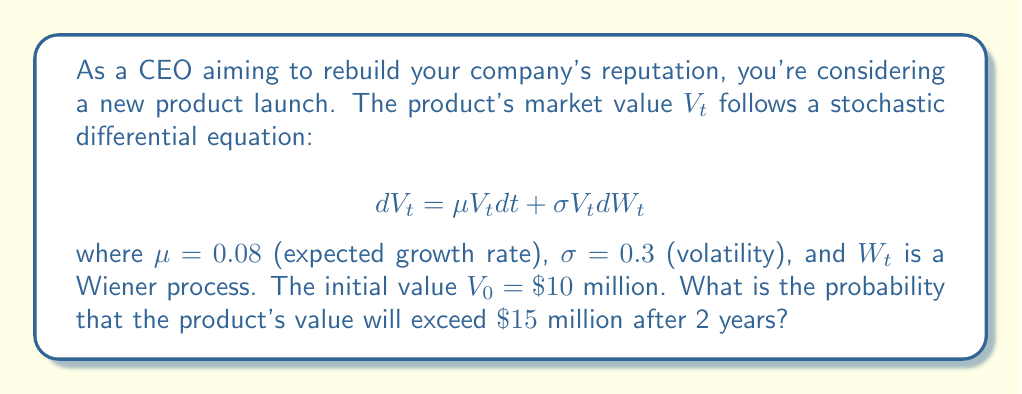Help me with this question. To solve this problem, we'll use the properties of geometric Brownian motion:

1) The solution to the SDE is given by:
   $$V_t = V_0 \exp\left(\left(\mu - \frac{\sigma^2}{2}\right)t + \sigma W_t\right)$$

2) $\ln(V_t)$ follows a normal distribution with:
   Mean: $\ln(V_0) + \left(\mu - \frac{\sigma^2}{2}\right)t$
   Variance: $\sigma^2 t$

3) We need to find $P(V_2 > 15)$, which is equivalent to $P(\ln(V_2) > \ln(15))$

4) Calculate the mean and variance:
   Mean = $\ln(10) + (0.08 - \frac{0.3^2}{2})2 = 2.3025 + 0.07 = 2.3725$
   Variance = $0.3^2 \cdot 2 = 0.18$

5) Standardize the normal distribution:
   $$Z = \frac{\ln(15) - 2.3725}{\sqrt{0.18}} = \frac{2.7081 - 2.3725}{0.4243} = 0.7908$$

6) The probability is given by $1 - \Phi(Z)$, where $\Phi$ is the standard normal CDF.

7) Using a standard normal table or calculator:
   $1 - \Phi(0.7908) \approx 0.2145$

Therefore, the probability that the product's value will exceed $15 million after 2 years is approximately 0.2145 or 21.45%.
Answer: 0.2145 